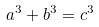<formula> <loc_0><loc_0><loc_500><loc_500>a ^ { 3 } + b ^ { 3 } = c ^ { 3 }</formula> 